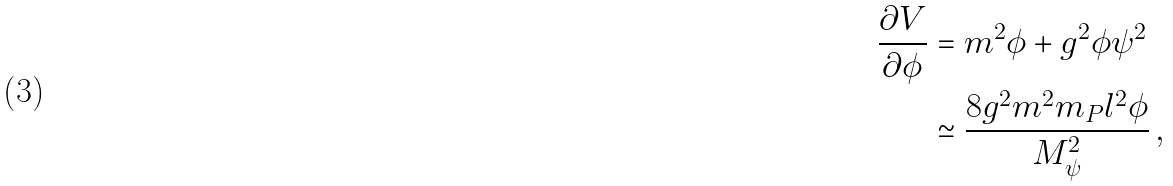<formula> <loc_0><loc_0><loc_500><loc_500>\frac { \partial V } { \partial \phi } & = m ^ { 2 } \phi + g ^ { 2 } \phi \psi ^ { 2 } \\ & \simeq \frac { 8 g ^ { 2 } m ^ { 2 } m _ { P } l ^ { 2 } \phi } { M _ { \psi } ^ { 2 } } \, ,</formula> 